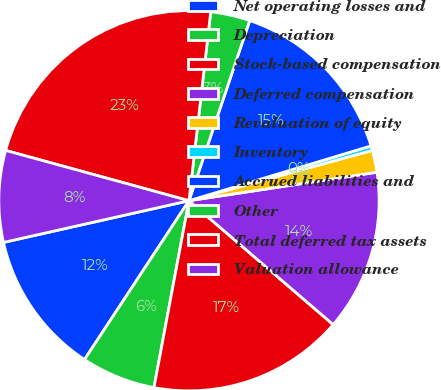Convert chart to OTSL. <chart><loc_0><loc_0><loc_500><loc_500><pie_chart><fcel>Net operating losses and<fcel>Depreciation<fcel>Stock-based compensation<fcel>Deferred compensation<fcel>Revaluation of equity<fcel>Inventory<fcel>Accrued liabilities and<fcel>Other<fcel>Total deferred tax assets<fcel>Valuation allowance<nl><fcel>12.22%<fcel>6.31%<fcel>16.65%<fcel>13.69%<fcel>1.87%<fcel>0.39%<fcel>15.17%<fcel>3.35%<fcel>22.56%<fcel>7.78%<nl></chart> 